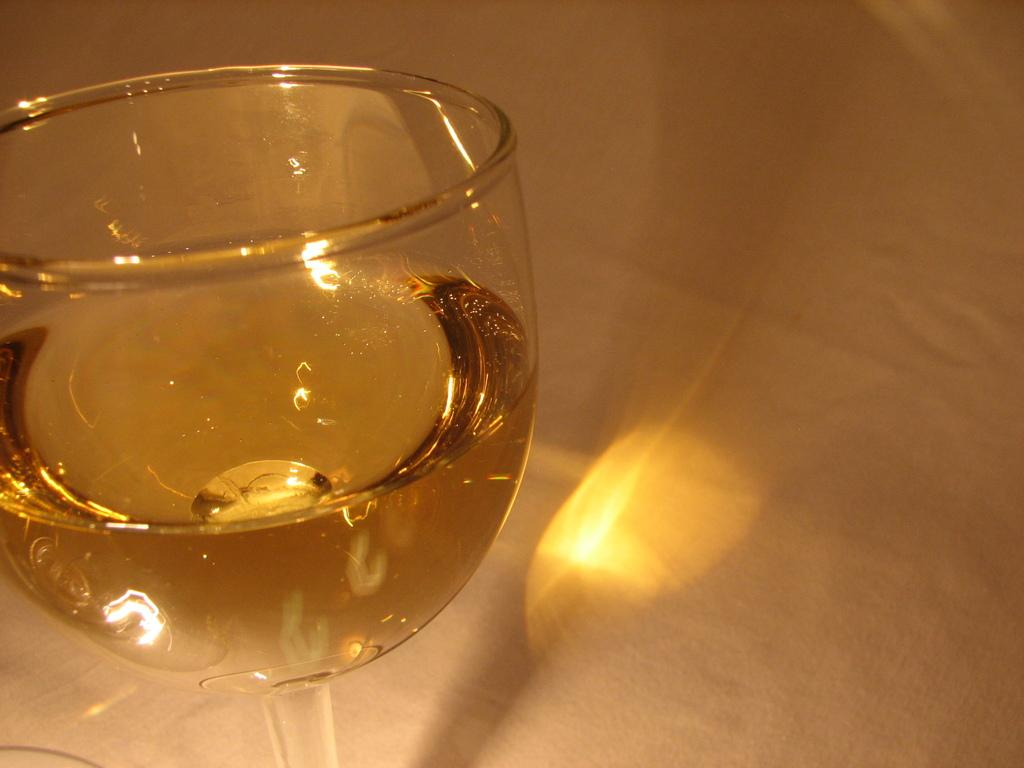What is in the glass that is visible in the image? There is a drink in the glass. Where is the glass located in the image? The glass is placed on a platform. What type of knife is being used by the grandmother in the image? There is no knife or grandmother present in the image. 